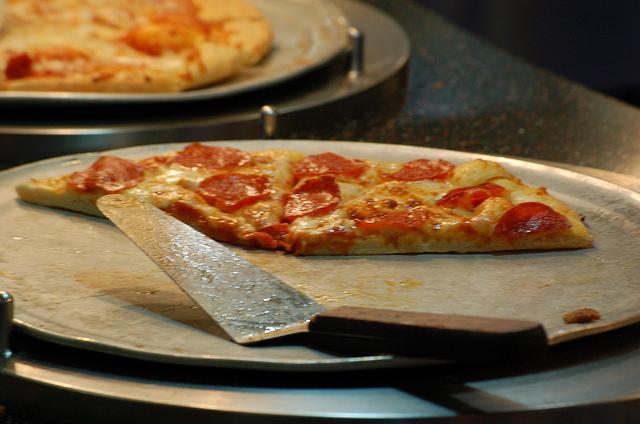What kind of pizza is in the foreground?
Answer briefly. Pepperoni. Why do some of the slices have crust on two sides?
Keep it brief. They don't. What color is the handle on the spatula?
Write a very short answer. Brown. Is this at a restaurant or at home?
Write a very short answer. Restaurant. Is there a fork?
Answer briefly. No. How  many utensils are on the plate?
Answer briefly. 1. 